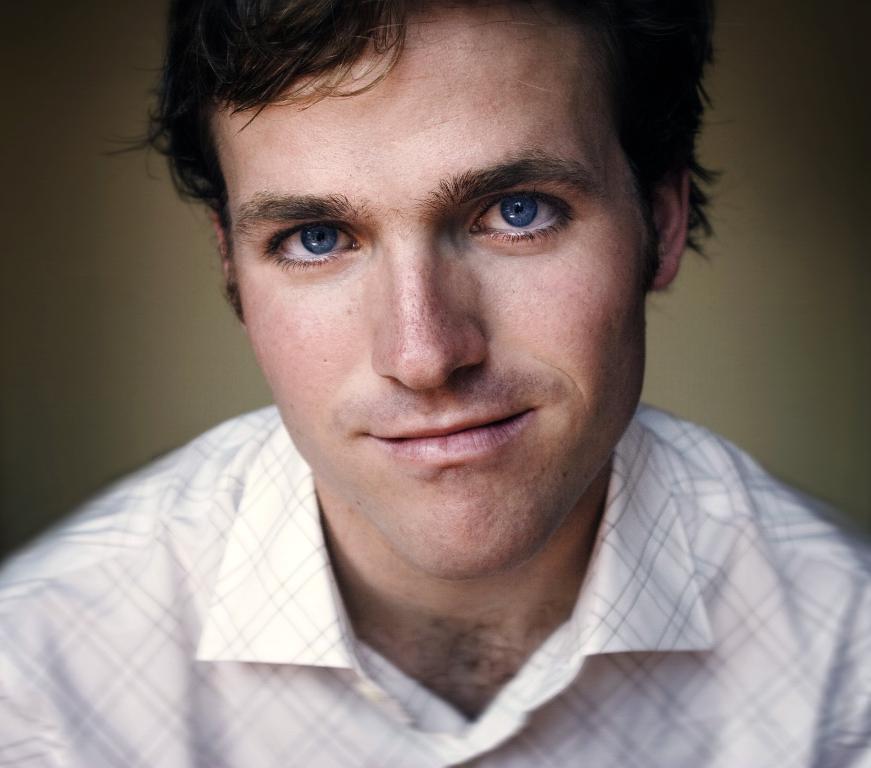Can you describe this image briefly? In this image in the front there is a man smiling. 